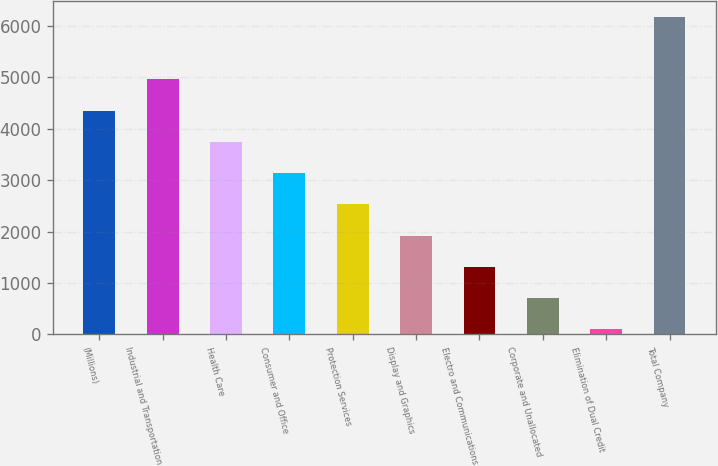Convert chart to OTSL. <chart><loc_0><loc_0><loc_500><loc_500><bar_chart><fcel>(Millions)<fcel>Industrial and Transportation<fcel>Health Care<fcel>Consumer and Office<fcel>Protection Services<fcel>Display and Graphics<fcel>Electro and Communications<fcel>Corporate and Unallocated<fcel>Elimination of Dual Credit<fcel>Total Company<nl><fcel>4354.9<fcel>4962.6<fcel>3747.2<fcel>3139.5<fcel>2531.8<fcel>1924.1<fcel>1316.4<fcel>708.7<fcel>101<fcel>6178<nl></chart> 